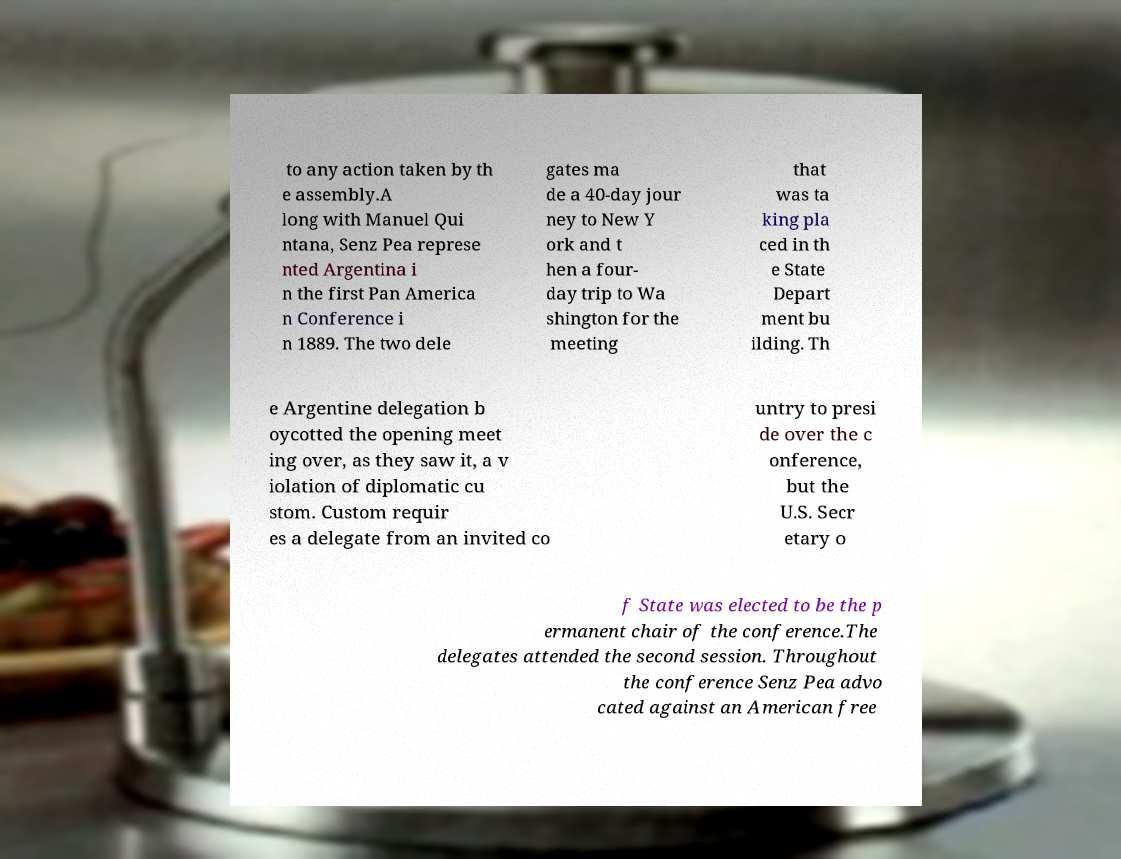I need the written content from this picture converted into text. Can you do that? to any action taken by th e assembly.A long with Manuel Qui ntana, Senz Pea represe nted Argentina i n the first Pan America n Conference i n 1889. The two dele gates ma de a 40-day jour ney to New Y ork and t hen a four- day trip to Wa shington for the meeting that was ta king pla ced in th e State Depart ment bu ilding. Th e Argentine delegation b oycotted the opening meet ing over, as they saw it, a v iolation of diplomatic cu stom. Custom requir es a delegate from an invited co untry to presi de over the c onference, but the U.S. Secr etary o f State was elected to be the p ermanent chair of the conference.The delegates attended the second session. Throughout the conference Senz Pea advo cated against an American free 